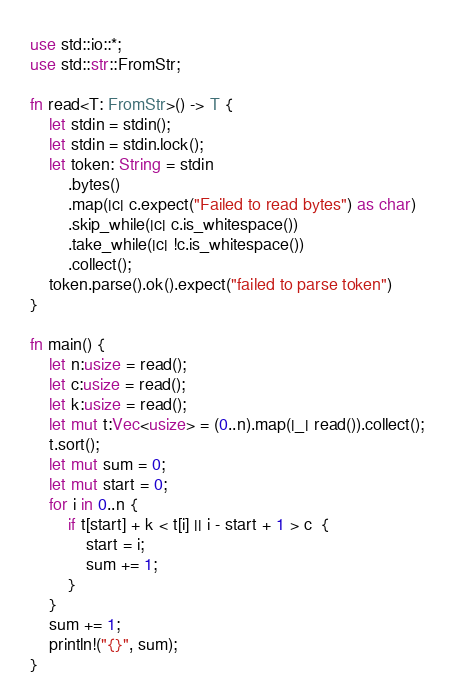<code> <loc_0><loc_0><loc_500><loc_500><_Rust_>use std::io::*;
use std::str::FromStr;

fn read<T: FromStr>() -> T {
    let stdin = stdin();
    let stdin = stdin.lock();
    let token: String = stdin
        .bytes()
        .map(|c| c.expect("Failed to read bytes") as char)
        .skip_while(|c| c.is_whitespace())
        .take_while(|c| !c.is_whitespace())
        .collect();
    token.parse().ok().expect("failed to parse token")
}

fn main() {
    let n:usize = read();
    let c:usize = read();
    let k:usize = read();
    let mut t:Vec<usize> = (0..n).map(|_| read()).collect();
    t.sort();
    let mut sum = 0;
    let mut start = 0;
    for i in 0..n {
        if t[start] + k < t[i] || i - start + 1 > c  {
            start = i;
            sum += 1;
        }
    }
    sum += 1;
    println!("{}", sum);
}</code> 